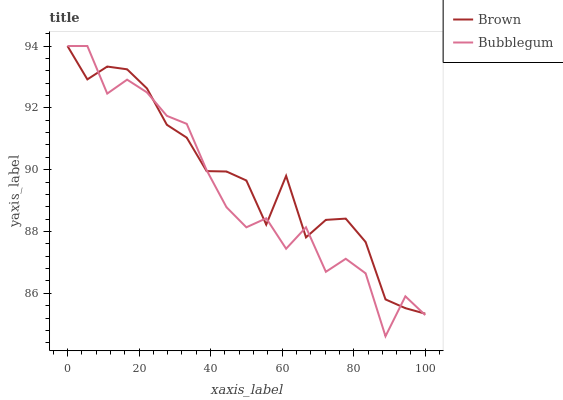Does Bubblegum have the minimum area under the curve?
Answer yes or no. Yes. Does Brown have the maximum area under the curve?
Answer yes or no. Yes. Does Bubblegum have the maximum area under the curve?
Answer yes or no. No. Is Brown the smoothest?
Answer yes or no. Yes. Is Bubblegum the roughest?
Answer yes or no. Yes. Is Bubblegum the smoothest?
Answer yes or no. No. Does Bubblegum have the lowest value?
Answer yes or no. Yes. Does Bubblegum have the highest value?
Answer yes or no. Yes. Does Bubblegum intersect Brown?
Answer yes or no. Yes. Is Bubblegum less than Brown?
Answer yes or no. No. Is Bubblegum greater than Brown?
Answer yes or no. No. 